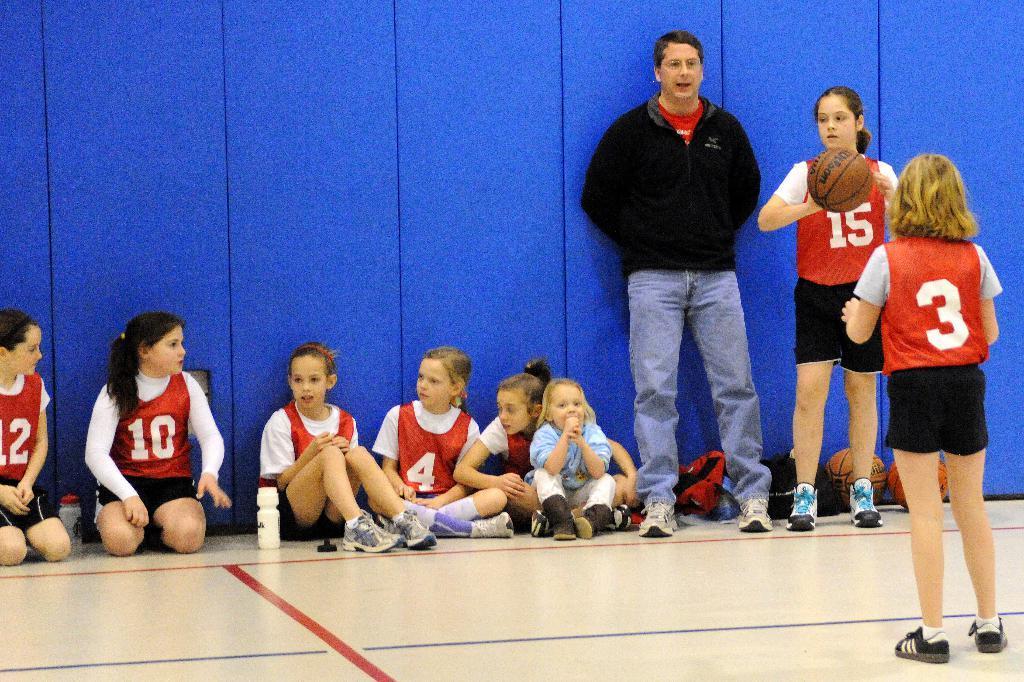Describe this image in one or two sentences. In this image we can see persons sitting and standing on the floor. In the background there is wall. On the right side of the image we can see a girl holding a basketball. 